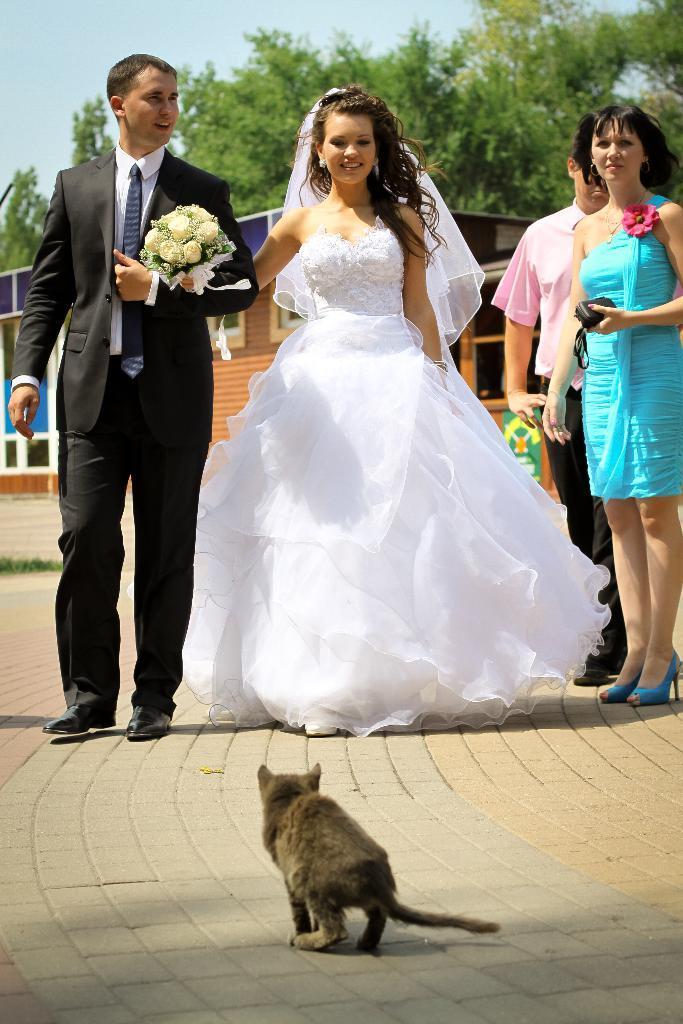Describe this image in one or two sentences. In this image we can see a group of people standing on the ground. In that a woman is holding a bouquet and the other is holding a pouch. On the bottom of the image we can see a cat on the surface. On the backside we can see a house with roof and windows, some trees and the sky. 